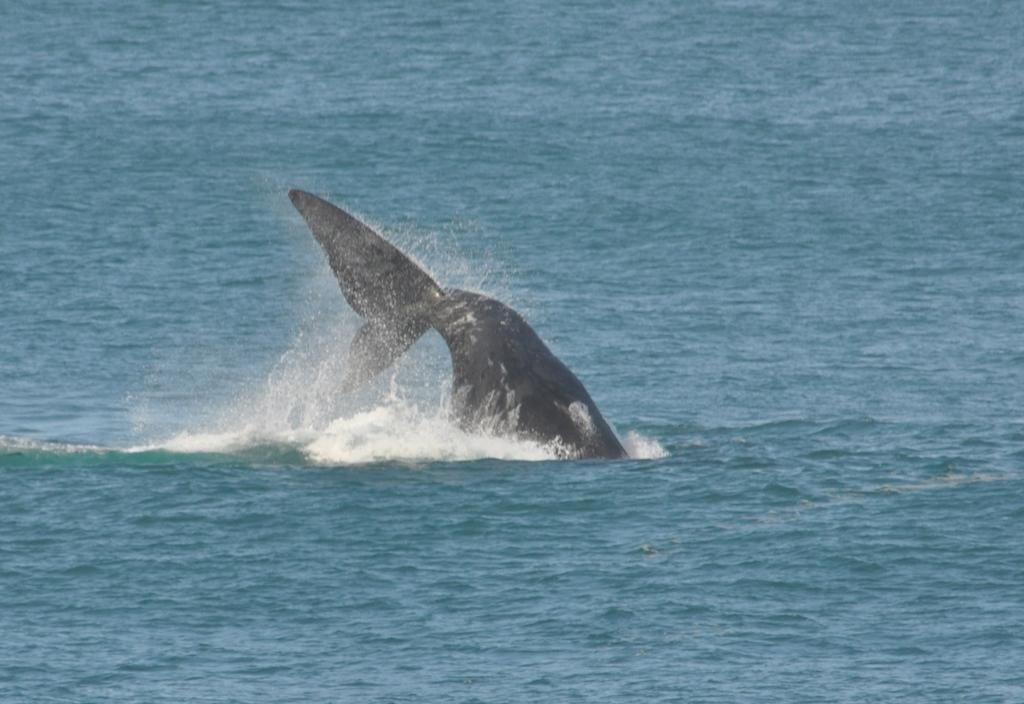What type of animal can be seen in the image? There is an aquatic animal in the image. What color is the water in the image? The water in the image is blue. What type of music is the spy listening to in the image? There is no spy or music present in the image; it features an aquatic animal in blue water. What does the tongue of the aquatic animal look like in the image? There is no tongue visible in the image, as it focuses on the aquatic animal and the blue water. 